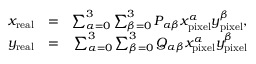<formula> <loc_0><loc_0><loc_500><loc_500>\begin{array} { r l r } { x _ { r e a l } } & { = } & { \sum _ { \alpha = 0 } ^ { 3 } \sum _ { \beta = 0 } ^ { 3 } P _ { \alpha \beta } x _ { p i x e l } ^ { \alpha } y _ { p i x e l } ^ { \beta } , } \\ { y _ { r e a l } } & { = } & { \sum _ { \alpha = 0 } ^ { 3 } \sum _ { \beta = 0 } ^ { 3 } Q _ { \alpha \beta } x _ { p i x e l } ^ { \alpha } y _ { p i x e l } ^ { \beta } } \end{array}</formula> 